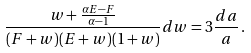Convert formula to latex. <formula><loc_0><loc_0><loc_500><loc_500>\frac { w + \frac { \alpha E - F } { \alpha - 1 } } { ( F + w ) ( E + w ) ( 1 + w ) } d w = 3 \frac { d a } { a } \, .</formula> 